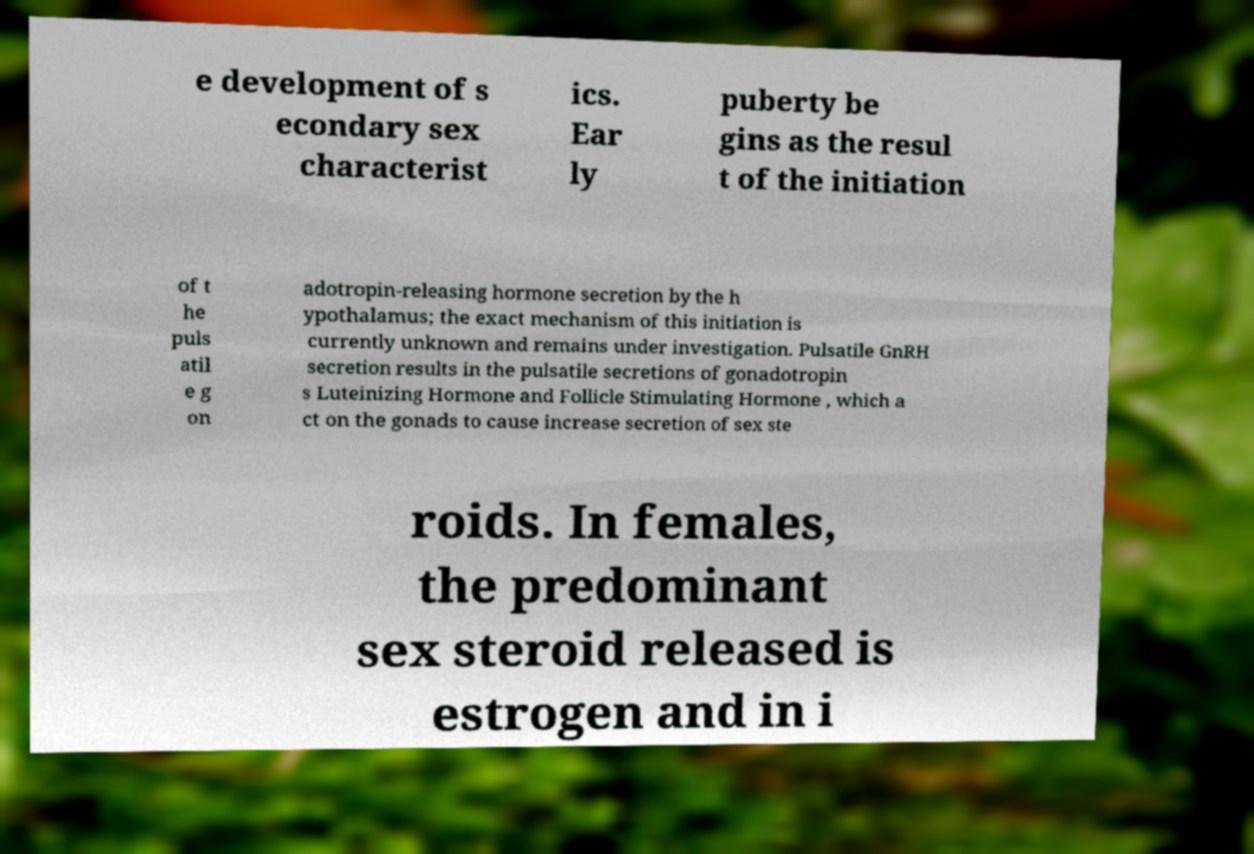Can you accurately transcribe the text from the provided image for me? e development of s econdary sex characterist ics. Ear ly puberty be gins as the resul t of the initiation of t he puls atil e g on adotropin-releasing hormone secretion by the h ypothalamus; the exact mechanism of this initiation is currently unknown and remains under investigation. Pulsatile GnRH secretion results in the pulsatile secretions of gonadotropin s Luteinizing Hormone and Follicle Stimulating Hormone , which a ct on the gonads to cause increase secretion of sex ste roids. In females, the predominant sex steroid released is estrogen and in i 